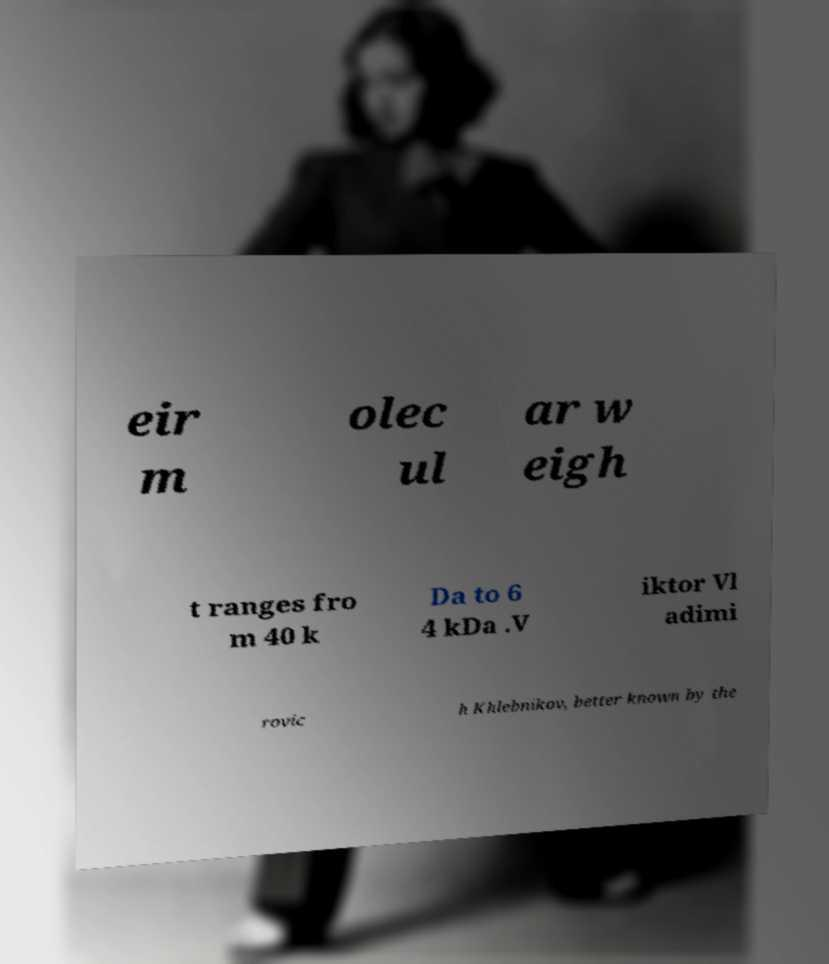There's text embedded in this image that I need extracted. Can you transcribe it verbatim? eir m olec ul ar w eigh t ranges fro m 40 k Da to 6 4 kDa .V iktor Vl adimi rovic h Khlebnikov, better known by the 